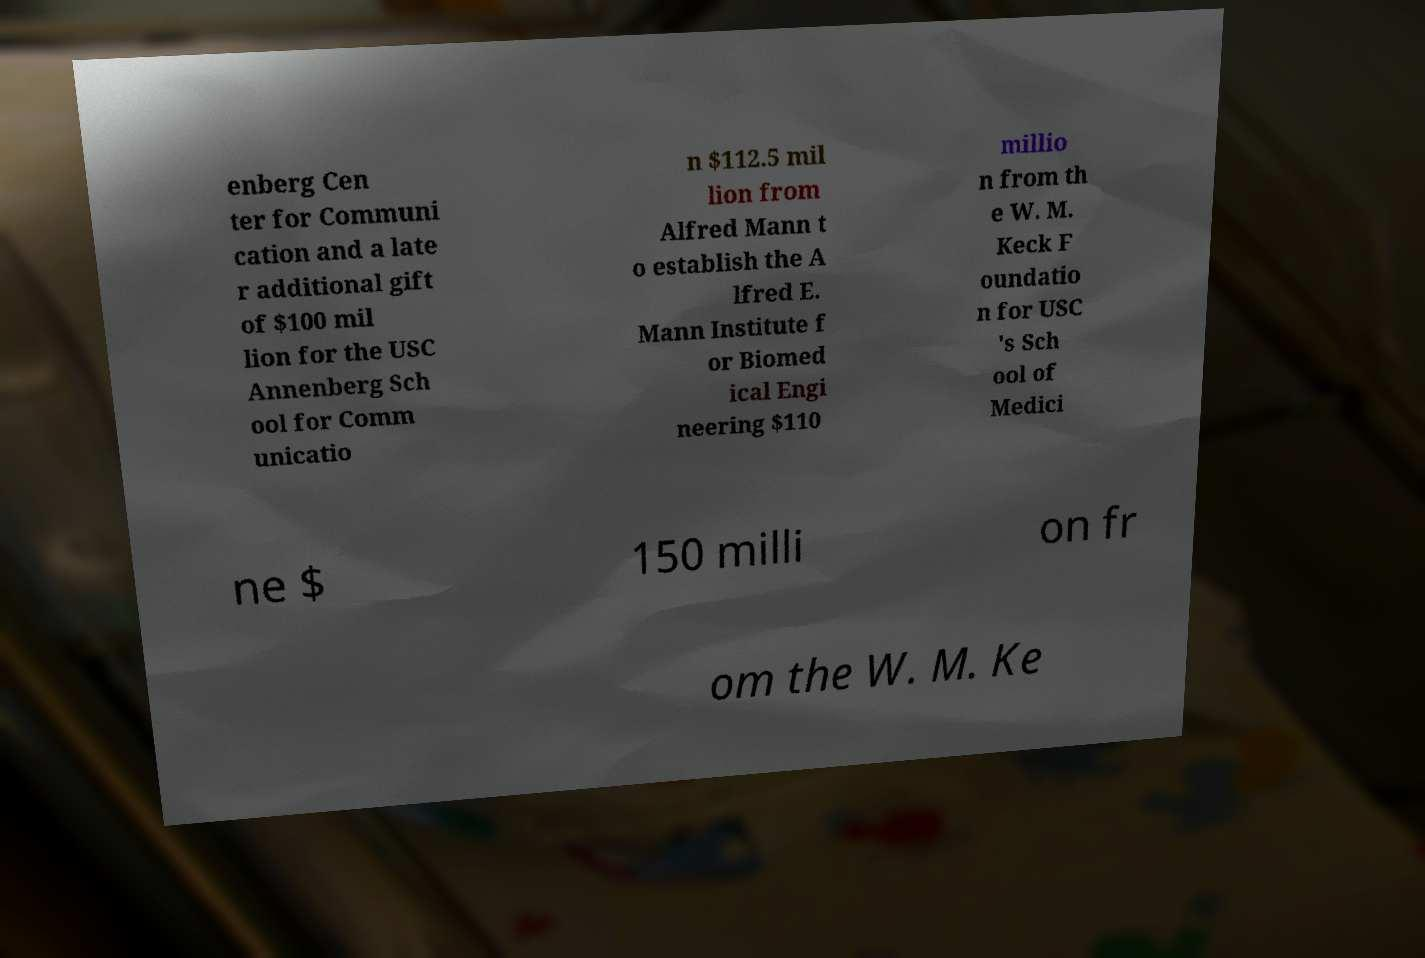Please read and relay the text visible in this image. What does it say? enberg Cen ter for Communi cation and a late r additional gift of $100 mil lion for the USC Annenberg Sch ool for Comm unicatio n $112.5 mil lion from Alfred Mann t o establish the A lfred E. Mann Institute f or Biomed ical Engi neering $110 millio n from th e W. M. Keck F oundatio n for USC 's Sch ool of Medici ne $ 150 milli on fr om the W. M. Ke 